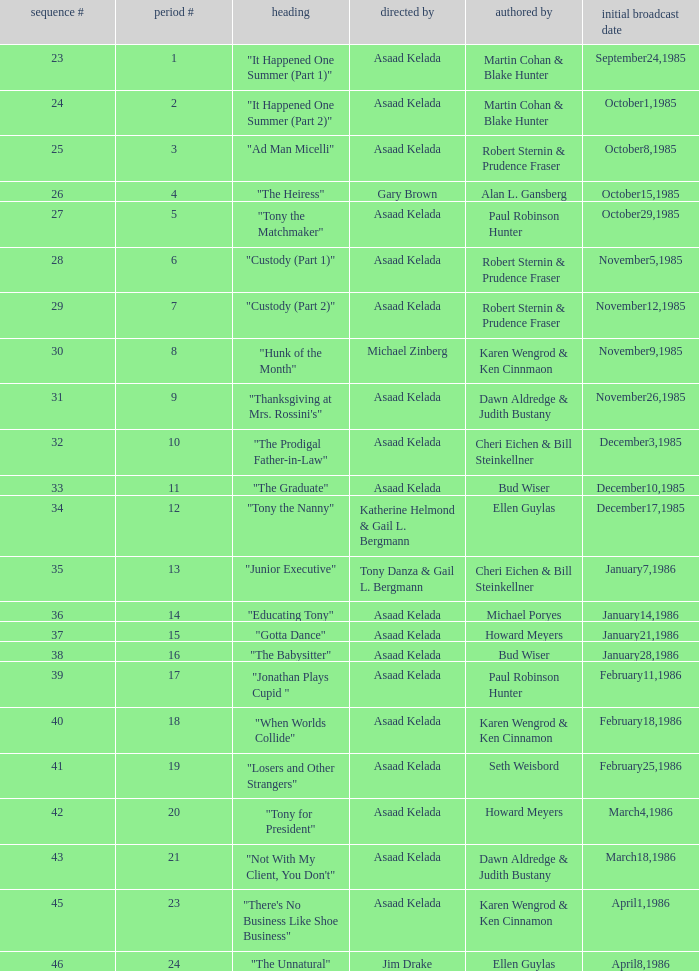What is the season where the episode "when worlds collide" was shown? 18.0. 